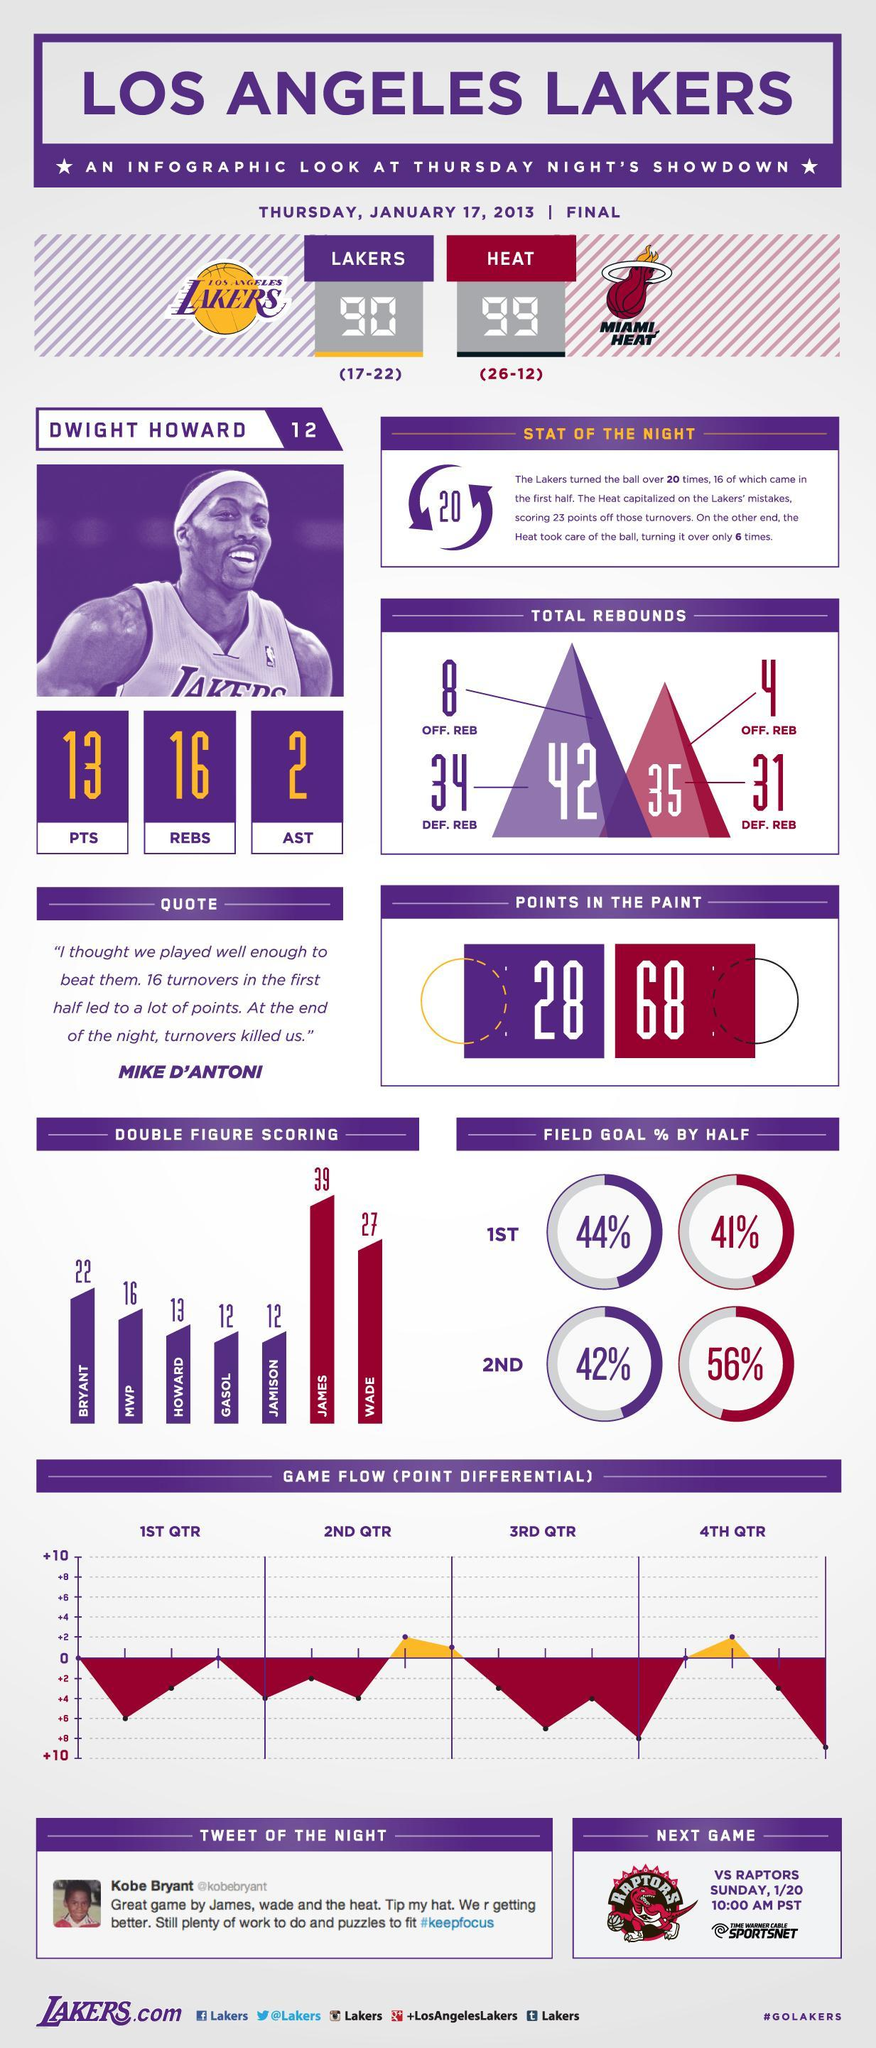What is the double-figure scoring of Gasol and Jamison, taken together?
Answer the question with a short phrase. 24 How many DEF. REB from Lakers and Miami Heat, taken together? 65 What is the number of AST from Dwight Howard? 2 What are the two names mentioned in this infographic from Miami Heat? James, Wade What is the number of REBS from Dwight Howard? 16 What is the double-figure scoring of James and Wade, taken together? 66 How many Off. REB from Lakers and Miami Heat, taken together? 12 